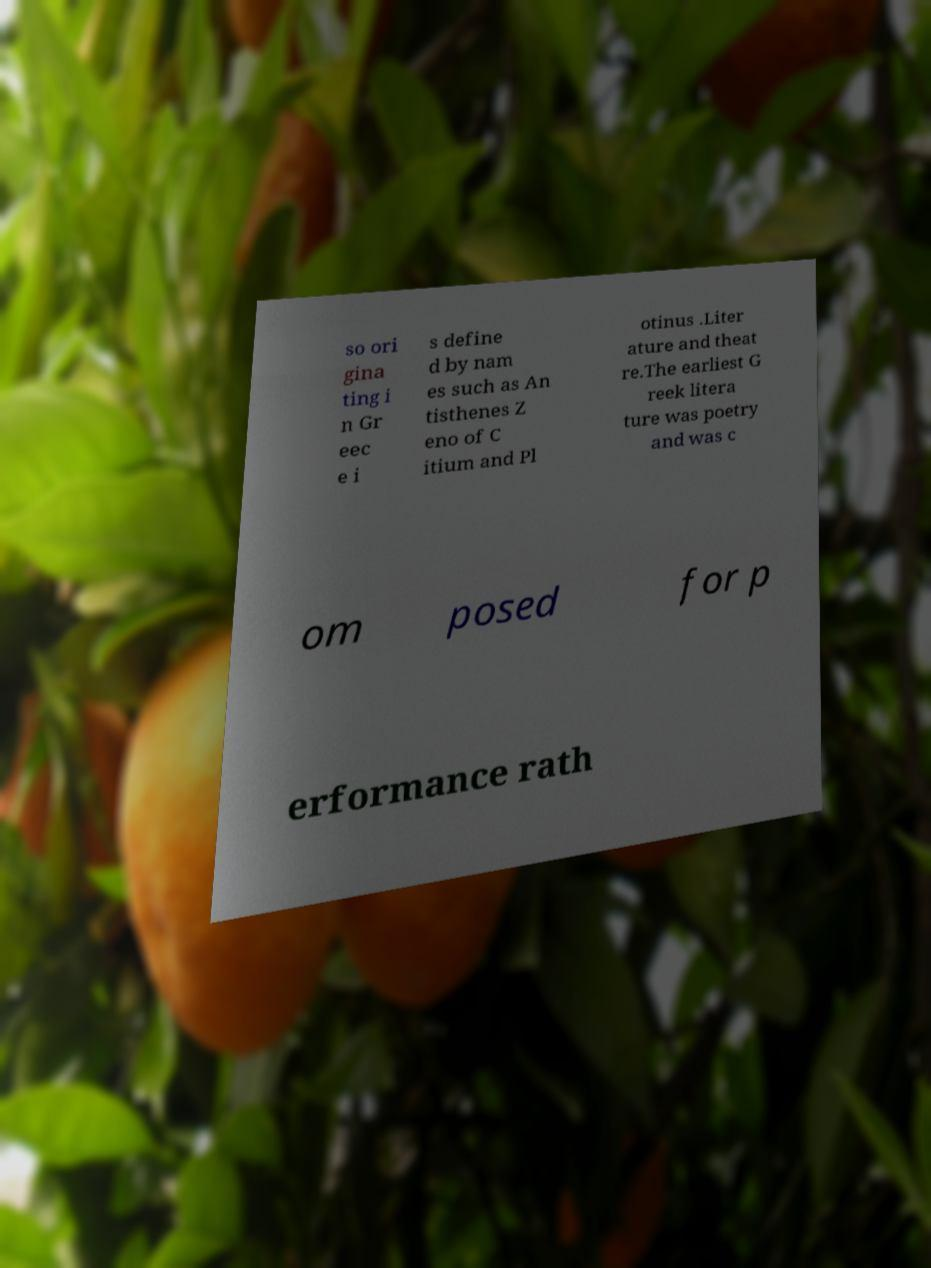Could you assist in decoding the text presented in this image and type it out clearly? so ori gina ting i n Gr eec e i s define d by nam es such as An tisthenes Z eno of C itium and Pl otinus .Liter ature and theat re.The earliest G reek litera ture was poetry and was c om posed for p erformance rath 